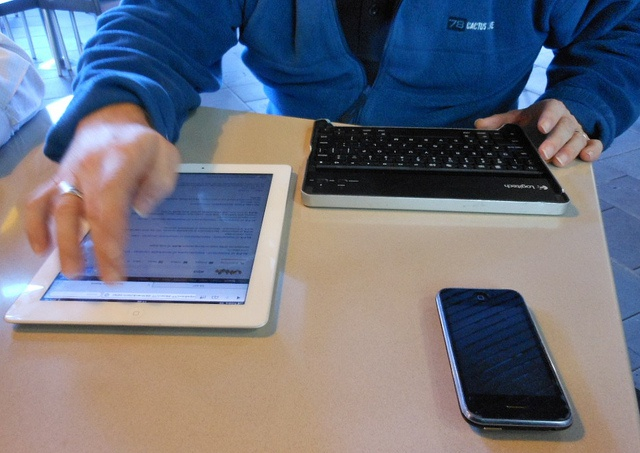Describe the objects in this image and their specific colors. I can see people in ivory, navy, black, salmon, and blue tones, laptop in white, black, gray, lightgray, and tan tones, keyboard in white, black, darkgray, gray, and lightblue tones, and cell phone in white, black, navy, gray, and darkgray tones in this image. 